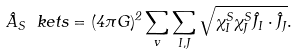<formula> <loc_0><loc_0><loc_500><loc_500>\hat { A } _ { S } \ k e t { s } = ( 4 \pi G ) ^ { 2 } \sum _ { v } \sum _ { I , J } \sqrt { \chi ^ { S } _ { I } \chi ^ { S } _ { J } \hat { J } _ { I } \cdot \hat { J } _ { J } } .</formula> 